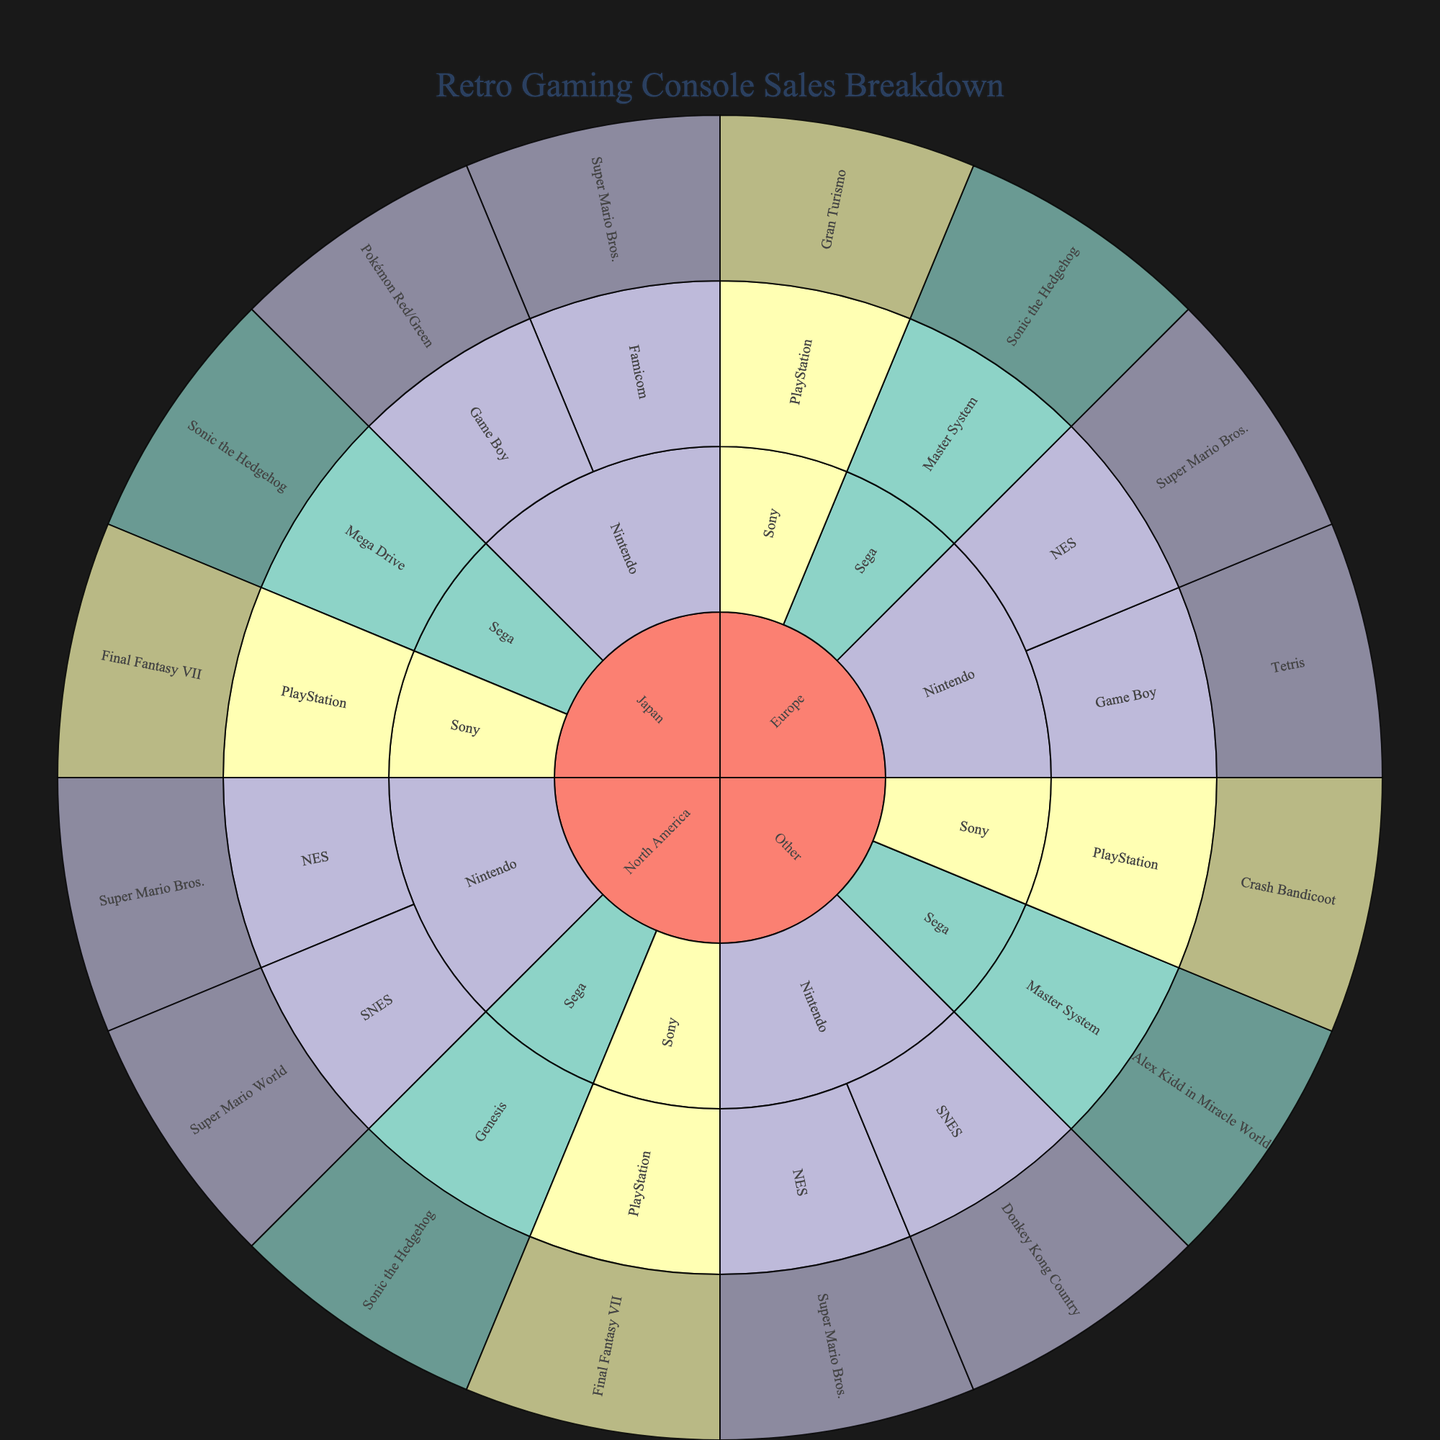What is the title of the sunburst plot? The title of the plot is usually displayed prominently at the top or near the top of the figure
Answer: Retro Gaming Console Sales Breakdown Which region has the highest number of manufacturers? Looking at the different sections in the outermost layer and counting the distinct manufacturers associated with each region will reveal the region with the highest number of manufacturers
Answer: North America Which console is associated with the best-selling game “Pokémon Red/Green”? Trace the segment for the best-selling game "Pokémon Red/Green" back to the console segment it belongs to
Answer: Game Boy How many best-selling games are there in the Europe region? Count the distinct segments under the Europe region that represent different best-selling games
Answer: 4 Which manufacturer has the most best-selling games across all regions? Count the number of best-selling game segments for each manufacturer across all regions and determine which manufacturer has the highest count
Answer: Nintendo How many regions include the game "Super Mario Bros." as a best seller? Check the regions where "Super Mario Bros." appears as the best-selling game segment
Answer: 4 Compare the number of best-selling games for Sony in Japan and North America. Which region has more? Count the best-selling games for Sony in both Japan (Final Fantasy VII) and North America (Final Fantasy VII) and compare the numbers
Answer: Equal (1 each) Which has more segments: Nintendo consoles in Europe or Sega consoles in Japan? Compare the number of segments under Nintendo in Europe with those under Sega in Japan by counting them
Answer: Nintendo consoles in Europe (3 vs. 2) What is the best-selling game for the Sega Genesis console? Trace the Sega Genesis console segment to see which best-selling game it is associated with
Answer: Sonic the Hedgehog 